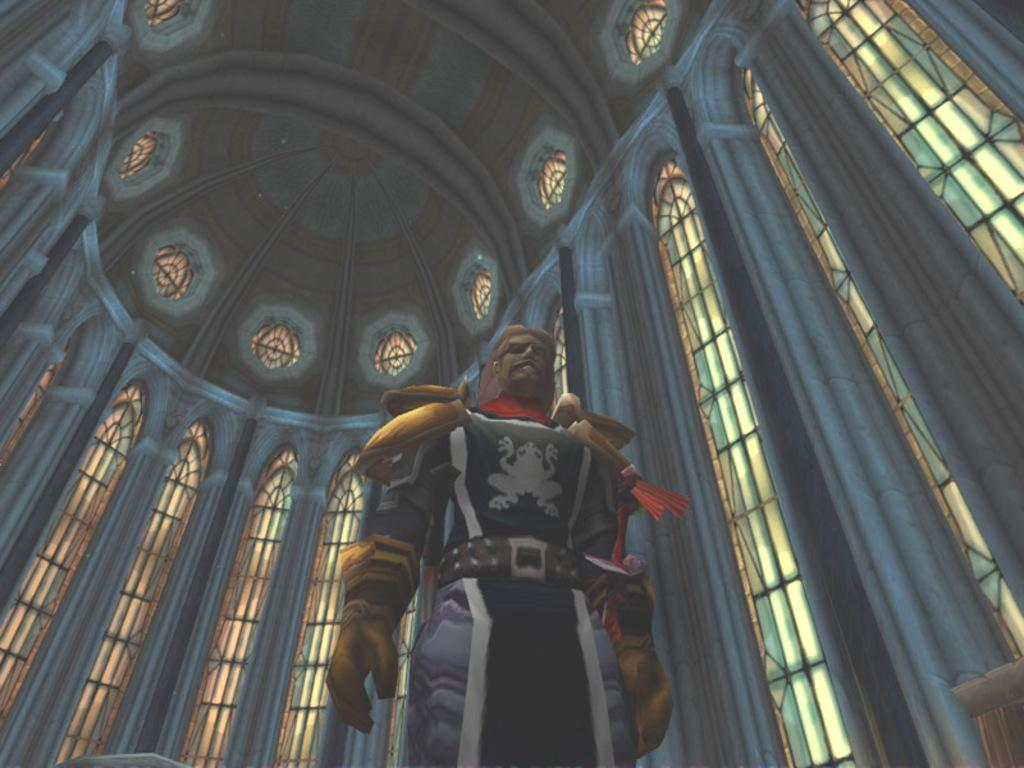What is the main subject of the image? There is a person in the center of the image. What can be seen in the background of the image? There are windows and pillars in the background of the image. What is at the top of the image? There is a ceiling at the top of the image. How many elbows does the person have in the image? The number of elbows cannot be determined from the image, as only the person's general position is visible. What event is taking place in the image related to the person's birth? There is no information about the person's birth in the image, so it cannot be determined if any event related to their birth is taking place. 